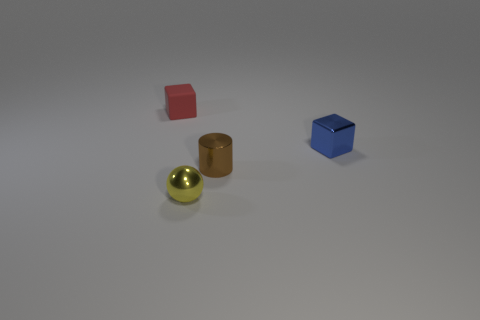Is there anything else that is made of the same material as the red object?
Your answer should be compact. No. There is a red thing; is its shape the same as the yellow object in front of the tiny blue shiny thing?
Your response must be concise. No. How many other things are there of the same size as the brown cylinder?
Keep it short and to the point. 3. What number of red things are either matte blocks or rubber cylinders?
Your response must be concise. 1. How many objects are both to the left of the metal cube and behind the small sphere?
Offer a terse response. 2. What is the material of the small cube that is on the left side of the block that is in front of the cube to the left of the tiny blue cube?
Provide a succinct answer. Rubber. What number of small red cubes have the same material as the brown cylinder?
Make the answer very short. 0. What is the shape of the red object that is the same size as the brown shiny cylinder?
Your answer should be very brief. Cube. There is a blue metal thing; are there any small metallic objects left of it?
Provide a short and direct response. Yes. Is there a gray rubber object of the same shape as the tiny brown shiny object?
Give a very brief answer. No. 